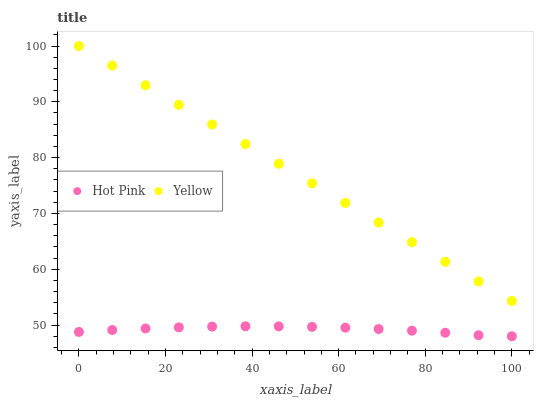Does Hot Pink have the minimum area under the curve?
Answer yes or no. Yes. Does Yellow have the maximum area under the curve?
Answer yes or no. Yes. Does Yellow have the minimum area under the curve?
Answer yes or no. No. Is Yellow the smoothest?
Answer yes or no. Yes. Is Hot Pink the roughest?
Answer yes or no. Yes. Is Yellow the roughest?
Answer yes or no. No. Does Hot Pink have the lowest value?
Answer yes or no. Yes. Does Yellow have the lowest value?
Answer yes or no. No. Does Yellow have the highest value?
Answer yes or no. Yes. Is Hot Pink less than Yellow?
Answer yes or no. Yes. Is Yellow greater than Hot Pink?
Answer yes or no. Yes. Does Hot Pink intersect Yellow?
Answer yes or no. No. 